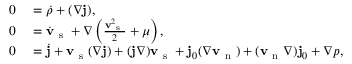<formula> <loc_0><loc_0><loc_500><loc_500>\begin{array} { r l } { 0 } & = \dot { \rho } + ( \nabla { j } ) , } \\ { 0 } & = { \dot { v } _ { s } } + \nabla \left ( \frac { { v _ { s } } ^ { 2 } } { 2 } + \mu \right ) , } \\ { 0 } & = \dot { { j } } + { v _ { s } } ( \nabla { j } ) + ( { j } \nabla ) { v _ { s } } + { j _ { 0 } } ( \nabla { v _ { n } } ) + ( { v _ { n } } \nabla ) { j _ { 0 } } + \nabla p , } \end{array}</formula> 